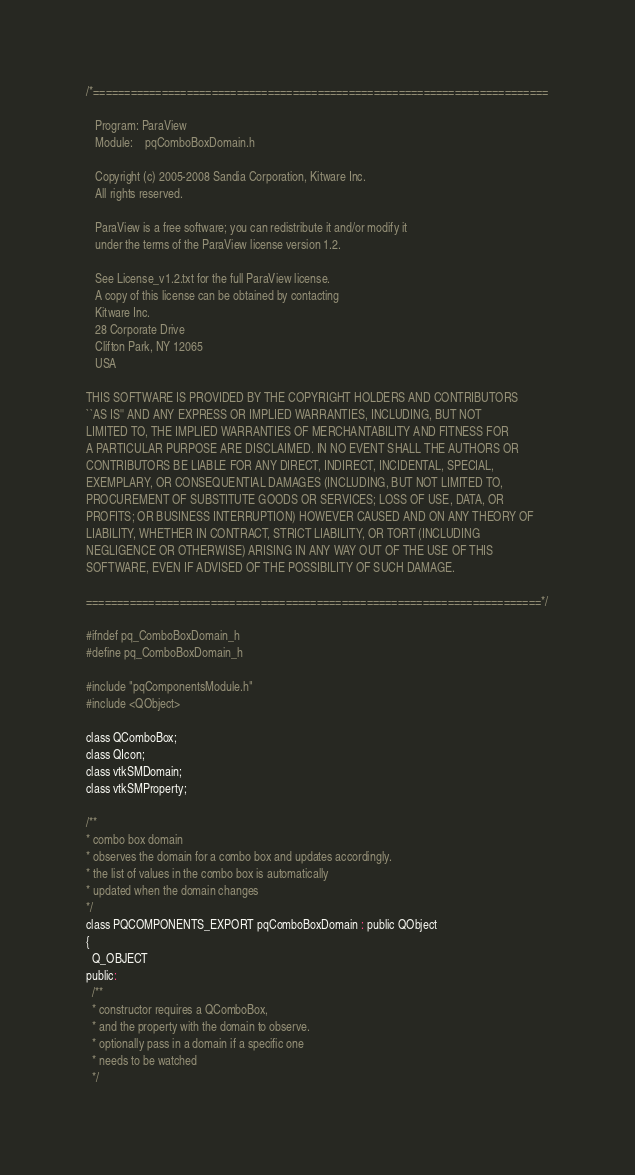Convert code to text. <code><loc_0><loc_0><loc_500><loc_500><_C_>/*=========================================================================

   Program: ParaView
   Module:    pqComboBoxDomain.h

   Copyright (c) 2005-2008 Sandia Corporation, Kitware Inc.
   All rights reserved.

   ParaView is a free software; you can redistribute it and/or modify it
   under the terms of the ParaView license version 1.2.

   See License_v1.2.txt for the full ParaView license.
   A copy of this license can be obtained by contacting
   Kitware Inc.
   28 Corporate Drive
   Clifton Park, NY 12065
   USA

THIS SOFTWARE IS PROVIDED BY THE COPYRIGHT HOLDERS AND CONTRIBUTORS
``AS IS'' AND ANY EXPRESS OR IMPLIED WARRANTIES, INCLUDING, BUT NOT
LIMITED TO, THE IMPLIED WARRANTIES OF MERCHANTABILITY AND FITNESS FOR
A PARTICULAR PURPOSE ARE DISCLAIMED. IN NO EVENT SHALL THE AUTHORS OR
CONTRIBUTORS BE LIABLE FOR ANY DIRECT, INDIRECT, INCIDENTAL, SPECIAL,
EXEMPLARY, OR CONSEQUENTIAL DAMAGES (INCLUDING, BUT NOT LIMITED TO,
PROCUREMENT OF SUBSTITUTE GOODS OR SERVICES; LOSS OF USE, DATA, OR
PROFITS; OR BUSINESS INTERRUPTION) HOWEVER CAUSED AND ON ANY THEORY OF
LIABILITY, WHETHER IN CONTRACT, STRICT LIABILITY, OR TORT (INCLUDING
NEGLIGENCE OR OTHERWISE) ARISING IN ANY WAY OUT OF THE USE OF THIS
SOFTWARE, EVEN IF ADVISED OF THE POSSIBILITY OF SUCH DAMAGE.

=========================================================================*/

#ifndef pq_ComboBoxDomain_h
#define pq_ComboBoxDomain_h

#include "pqComponentsModule.h"
#include <QObject>

class QComboBox;
class QIcon;
class vtkSMDomain;
class vtkSMProperty;

/**
* combo box domain
* observes the domain for a combo box and updates accordingly.
* the list of values in the combo box is automatically
* updated when the domain changes
*/
class PQCOMPONENTS_EXPORT pqComboBoxDomain : public QObject
{
  Q_OBJECT
public:
  /**
  * constructor requires a QComboBox,
  * and the property with the domain to observe.
  * optionally pass in a domain if a specific one
  * needs to be watched
  */</code> 